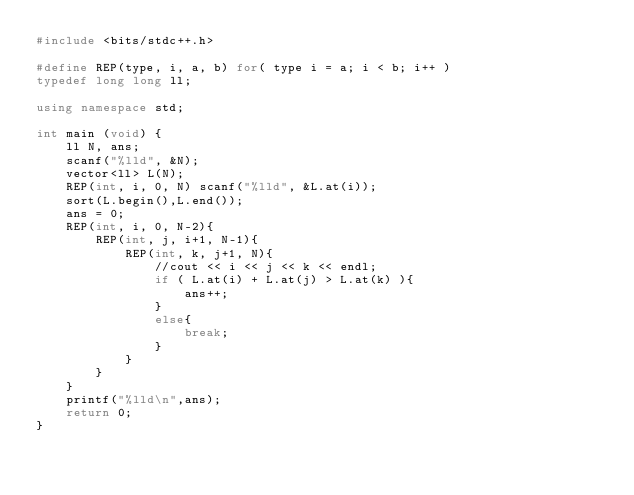<code> <loc_0><loc_0><loc_500><loc_500><_C++_>#include <bits/stdc++.h>

#define REP(type, i, a, b) for( type i = a; i < b; i++ )
typedef long long ll;

using namespace std;

int main (void) {
    ll N, ans;
    scanf("%lld", &N);
    vector<ll> L(N);
    REP(int, i, 0, N) scanf("%lld", &L.at(i));
    sort(L.begin(),L.end());
    ans = 0;
    REP(int, i, 0, N-2){
        REP(int, j, i+1, N-1){
            REP(int, k, j+1, N){
                //cout << i << j << k << endl;
                if ( L.at(i) + L.at(j) > L.at(k) ){
                    ans++;
                }
                else{
                    break;
                }
            }
        }
    }
    printf("%lld\n",ans);
    return 0;
}</code> 